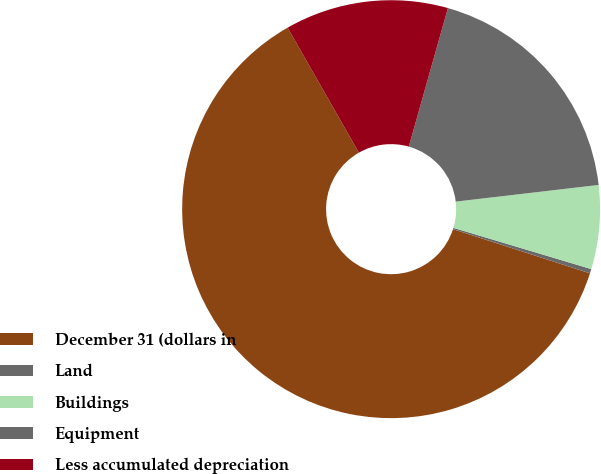<chart> <loc_0><loc_0><loc_500><loc_500><pie_chart><fcel>December 31 (dollars in<fcel>Land<fcel>Buildings<fcel>Equipment<fcel>Less accumulated depreciation<nl><fcel>61.79%<fcel>0.34%<fcel>6.48%<fcel>18.77%<fcel>12.63%<nl></chart> 